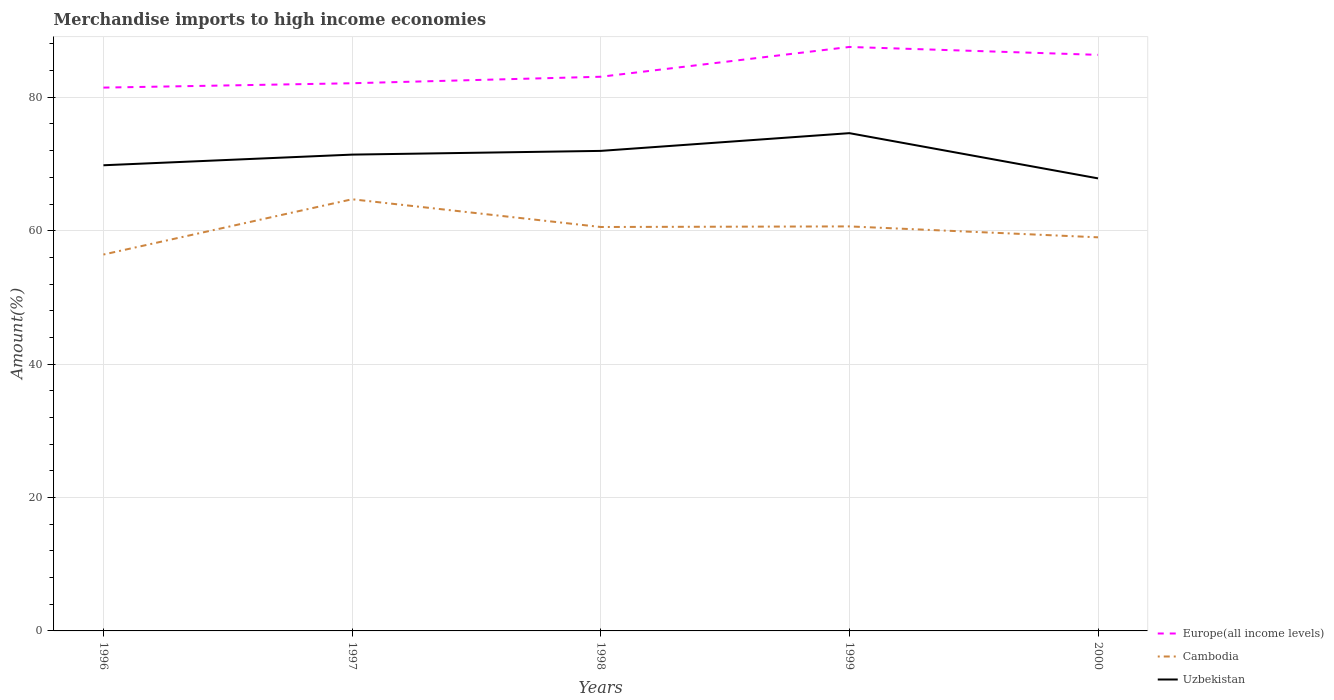Is the number of lines equal to the number of legend labels?
Make the answer very short. Yes. Across all years, what is the maximum percentage of amount earned from merchandise imports in Europe(all income levels)?
Give a very brief answer. 81.45. What is the total percentage of amount earned from merchandise imports in Cambodia in the graph?
Make the answer very short. 1.64. What is the difference between the highest and the second highest percentage of amount earned from merchandise imports in Uzbekistan?
Your answer should be very brief. 6.78. Is the percentage of amount earned from merchandise imports in Uzbekistan strictly greater than the percentage of amount earned from merchandise imports in Cambodia over the years?
Offer a terse response. No. How many years are there in the graph?
Ensure brevity in your answer.  5. Are the values on the major ticks of Y-axis written in scientific E-notation?
Provide a short and direct response. No. How many legend labels are there?
Offer a terse response. 3. How are the legend labels stacked?
Give a very brief answer. Vertical. What is the title of the graph?
Provide a short and direct response. Merchandise imports to high income economies. Does "South Africa" appear as one of the legend labels in the graph?
Make the answer very short. No. What is the label or title of the X-axis?
Your answer should be very brief. Years. What is the label or title of the Y-axis?
Your answer should be compact. Amount(%). What is the Amount(%) in Europe(all income levels) in 1996?
Your answer should be compact. 81.45. What is the Amount(%) of Cambodia in 1996?
Provide a succinct answer. 56.43. What is the Amount(%) of Uzbekistan in 1996?
Make the answer very short. 69.81. What is the Amount(%) of Europe(all income levels) in 1997?
Make the answer very short. 82.1. What is the Amount(%) of Cambodia in 1997?
Ensure brevity in your answer.  64.71. What is the Amount(%) in Uzbekistan in 1997?
Your response must be concise. 71.41. What is the Amount(%) of Europe(all income levels) in 1998?
Your answer should be compact. 83.08. What is the Amount(%) of Cambodia in 1998?
Provide a short and direct response. 60.55. What is the Amount(%) of Uzbekistan in 1998?
Ensure brevity in your answer.  71.96. What is the Amount(%) of Europe(all income levels) in 1999?
Ensure brevity in your answer.  87.55. What is the Amount(%) in Cambodia in 1999?
Your response must be concise. 60.64. What is the Amount(%) of Uzbekistan in 1999?
Give a very brief answer. 74.62. What is the Amount(%) in Europe(all income levels) in 2000?
Make the answer very short. 86.36. What is the Amount(%) in Cambodia in 2000?
Your response must be concise. 59.01. What is the Amount(%) of Uzbekistan in 2000?
Your response must be concise. 67.84. Across all years, what is the maximum Amount(%) in Europe(all income levels)?
Your response must be concise. 87.55. Across all years, what is the maximum Amount(%) of Cambodia?
Offer a terse response. 64.71. Across all years, what is the maximum Amount(%) of Uzbekistan?
Keep it short and to the point. 74.62. Across all years, what is the minimum Amount(%) of Europe(all income levels)?
Make the answer very short. 81.45. Across all years, what is the minimum Amount(%) in Cambodia?
Provide a succinct answer. 56.43. Across all years, what is the minimum Amount(%) of Uzbekistan?
Offer a terse response. 67.84. What is the total Amount(%) in Europe(all income levels) in the graph?
Your answer should be compact. 420.54. What is the total Amount(%) in Cambodia in the graph?
Provide a short and direct response. 301.34. What is the total Amount(%) in Uzbekistan in the graph?
Keep it short and to the point. 355.65. What is the difference between the Amount(%) in Europe(all income levels) in 1996 and that in 1997?
Your answer should be compact. -0.65. What is the difference between the Amount(%) in Cambodia in 1996 and that in 1997?
Ensure brevity in your answer.  -8.29. What is the difference between the Amount(%) of Uzbekistan in 1996 and that in 1997?
Provide a short and direct response. -1.6. What is the difference between the Amount(%) of Europe(all income levels) in 1996 and that in 1998?
Provide a short and direct response. -1.63. What is the difference between the Amount(%) of Cambodia in 1996 and that in 1998?
Provide a succinct answer. -4.13. What is the difference between the Amount(%) in Uzbekistan in 1996 and that in 1998?
Provide a short and direct response. -2.15. What is the difference between the Amount(%) of Europe(all income levels) in 1996 and that in 1999?
Give a very brief answer. -6.09. What is the difference between the Amount(%) of Cambodia in 1996 and that in 1999?
Provide a succinct answer. -4.22. What is the difference between the Amount(%) in Uzbekistan in 1996 and that in 1999?
Provide a succinct answer. -4.81. What is the difference between the Amount(%) of Europe(all income levels) in 1996 and that in 2000?
Provide a short and direct response. -4.91. What is the difference between the Amount(%) in Cambodia in 1996 and that in 2000?
Ensure brevity in your answer.  -2.58. What is the difference between the Amount(%) of Uzbekistan in 1996 and that in 2000?
Offer a terse response. 1.97. What is the difference between the Amount(%) in Europe(all income levels) in 1997 and that in 1998?
Provide a succinct answer. -0.97. What is the difference between the Amount(%) of Cambodia in 1997 and that in 1998?
Keep it short and to the point. 4.16. What is the difference between the Amount(%) in Uzbekistan in 1997 and that in 1998?
Your response must be concise. -0.56. What is the difference between the Amount(%) of Europe(all income levels) in 1997 and that in 1999?
Your answer should be very brief. -5.44. What is the difference between the Amount(%) of Cambodia in 1997 and that in 1999?
Your answer should be very brief. 4.07. What is the difference between the Amount(%) of Uzbekistan in 1997 and that in 1999?
Offer a very short reply. -3.22. What is the difference between the Amount(%) in Europe(all income levels) in 1997 and that in 2000?
Provide a short and direct response. -4.26. What is the difference between the Amount(%) of Cambodia in 1997 and that in 2000?
Keep it short and to the point. 5.7. What is the difference between the Amount(%) in Uzbekistan in 1997 and that in 2000?
Provide a short and direct response. 3.56. What is the difference between the Amount(%) of Europe(all income levels) in 1998 and that in 1999?
Offer a very short reply. -4.47. What is the difference between the Amount(%) of Cambodia in 1998 and that in 1999?
Your answer should be compact. -0.09. What is the difference between the Amount(%) in Uzbekistan in 1998 and that in 1999?
Your answer should be compact. -2.66. What is the difference between the Amount(%) in Europe(all income levels) in 1998 and that in 2000?
Provide a short and direct response. -3.28. What is the difference between the Amount(%) in Cambodia in 1998 and that in 2000?
Your answer should be very brief. 1.55. What is the difference between the Amount(%) of Uzbekistan in 1998 and that in 2000?
Your answer should be compact. 4.12. What is the difference between the Amount(%) in Europe(all income levels) in 1999 and that in 2000?
Offer a very short reply. 1.18. What is the difference between the Amount(%) in Cambodia in 1999 and that in 2000?
Provide a short and direct response. 1.64. What is the difference between the Amount(%) of Uzbekistan in 1999 and that in 2000?
Provide a succinct answer. 6.78. What is the difference between the Amount(%) in Europe(all income levels) in 1996 and the Amount(%) in Cambodia in 1997?
Give a very brief answer. 16.74. What is the difference between the Amount(%) in Europe(all income levels) in 1996 and the Amount(%) in Uzbekistan in 1997?
Give a very brief answer. 10.04. What is the difference between the Amount(%) of Cambodia in 1996 and the Amount(%) of Uzbekistan in 1997?
Provide a short and direct response. -14.98. What is the difference between the Amount(%) in Europe(all income levels) in 1996 and the Amount(%) in Cambodia in 1998?
Keep it short and to the point. 20.9. What is the difference between the Amount(%) of Europe(all income levels) in 1996 and the Amount(%) of Uzbekistan in 1998?
Offer a very short reply. 9.49. What is the difference between the Amount(%) of Cambodia in 1996 and the Amount(%) of Uzbekistan in 1998?
Ensure brevity in your answer.  -15.54. What is the difference between the Amount(%) in Europe(all income levels) in 1996 and the Amount(%) in Cambodia in 1999?
Keep it short and to the point. 20.81. What is the difference between the Amount(%) of Europe(all income levels) in 1996 and the Amount(%) of Uzbekistan in 1999?
Ensure brevity in your answer.  6.83. What is the difference between the Amount(%) of Cambodia in 1996 and the Amount(%) of Uzbekistan in 1999?
Keep it short and to the point. -18.2. What is the difference between the Amount(%) in Europe(all income levels) in 1996 and the Amount(%) in Cambodia in 2000?
Offer a very short reply. 22.44. What is the difference between the Amount(%) of Europe(all income levels) in 1996 and the Amount(%) of Uzbekistan in 2000?
Provide a succinct answer. 13.61. What is the difference between the Amount(%) of Cambodia in 1996 and the Amount(%) of Uzbekistan in 2000?
Ensure brevity in your answer.  -11.42. What is the difference between the Amount(%) in Europe(all income levels) in 1997 and the Amount(%) in Cambodia in 1998?
Your answer should be very brief. 21.55. What is the difference between the Amount(%) in Europe(all income levels) in 1997 and the Amount(%) in Uzbekistan in 1998?
Offer a terse response. 10.14. What is the difference between the Amount(%) of Cambodia in 1997 and the Amount(%) of Uzbekistan in 1998?
Provide a succinct answer. -7.25. What is the difference between the Amount(%) of Europe(all income levels) in 1997 and the Amount(%) of Cambodia in 1999?
Provide a succinct answer. 21.46. What is the difference between the Amount(%) in Europe(all income levels) in 1997 and the Amount(%) in Uzbekistan in 1999?
Make the answer very short. 7.48. What is the difference between the Amount(%) of Cambodia in 1997 and the Amount(%) of Uzbekistan in 1999?
Offer a terse response. -9.91. What is the difference between the Amount(%) of Europe(all income levels) in 1997 and the Amount(%) of Cambodia in 2000?
Your answer should be compact. 23.1. What is the difference between the Amount(%) of Europe(all income levels) in 1997 and the Amount(%) of Uzbekistan in 2000?
Your answer should be compact. 14.26. What is the difference between the Amount(%) of Cambodia in 1997 and the Amount(%) of Uzbekistan in 2000?
Your answer should be compact. -3.13. What is the difference between the Amount(%) of Europe(all income levels) in 1998 and the Amount(%) of Cambodia in 1999?
Offer a terse response. 22.44. What is the difference between the Amount(%) of Europe(all income levels) in 1998 and the Amount(%) of Uzbekistan in 1999?
Provide a succinct answer. 8.46. What is the difference between the Amount(%) in Cambodia in 1998 and the Amount(%) in Uzbekistan in 1999?
Make the answer very short. -14.07. What is the difference between the Amount(%) in Europe(all income levels) in 1998 and the Amount(%) in Cambodia in 2000?
Your response must be concise. 24.07. What is the difference between the Amount(%) in Europe(all income levels) in 1998 and the Amount(%) in Uzbekistan in 2000?
Offer a very short reply. 15.23. What is the difference between the Amount(%) in Cambodia in 1998 and the Amount(%) in Uzbekistan in 2000?
Your answer should be compact. -7.29. What is the difference between the Amount(%) of Europe(all income levels) in 1999 and the Amount(%) of Cambodia in 2000?
Give a very brief answer. 28.54. What is the difference between the Amount(%) in Europe(all income levels) in 1999 and the Amount(%) in Uzbekistan in 2000?
Offer a very short reply. 19.7. What is the difference between the Amount(%) of Cambodia in 1999 and the Amount(%) of Uzbekistan in 2000?
Offer a terse response. -7.2. What is the average Amount(%) of Europe(all income levels) per year?
Offer a very short reply. 84.11. What is the average Amount(%) in Cambodia per year?
Provide a succinct answer. 60.27. What is the average Amount(%) of Uzbekistan per year?
Your answer should be compact. 71.13. In the year 1996, what is the difference between the Amount(%) of Europe(all income levels) and Amount(%) of Cambodia?
Provide a short and direct response. 25.03. In the year 1996, what is the difference between the Amount(%) in Europe(all income levels) and Amount(%) in Uzbekistan?
Offer a terse response. 11.64. In the year 1996, what is the difference between the Amount(%) in Cambodia and Amount(%) in Uzbekistan?
Offer a terse response. -13.38. In the year 1997, what is the difference between the Amount(%) of Europe(all income levels) and Amount(%) of Cambodia?
Provide a succinct answer. 17.39. In the year 1997, what is the difference between the Amount(%) of Europe(all income levels) and Amount(%) of Uzbekistan?
Provide a short and direct response. 10.7. In the year 1997, what is the difference between the Amount(%) of Cambodia and Amount(%) of Uzbekistan?
Make the answer very short. -6.69. In the year 1998, what is the difference between the Amount(%) of Europe(all income levels) and Amount(%) of Cambodia?
Keep it short and to the point. 22.52. In the year 1998, what is the difference between the Amount(%) in Europe(all income levels) and Amount(%) in Uzbekistan?
Your answer should be compact. 11.11. In the year 1998, what is the difference between the Amount(%) of Cambodia and Amount(%) of Uzbekistan?
Offer a very short reply. -11.41. In the year 1999, what is the difference between the Amount(%) of Europe(all income levels) and Amount(%) of Cambodia?
Your response must be concise. 26.9. In the year 1999, what is the difference between the Amount(%) of Europe(all income levels) and Amount(%) of Uzbekistan?
Your response must be concise. 12.92. In the year 1999, what is the difference between the Amount(%) of Cambodia and Amount(%) of Uzbekistan?
Your response must be concise. -13.98. In the year 2000, what is the difference between the Amount(%) of Europe(all income levels) and Amount(%) of Cambodia?
Offer a terse response. 27.35. In the year 2000, what is the difference between the Amount(%) in Europe(all income levels) and Amount(%) in Uzbekistan?
Your answer should be compact. 18.52. In the year 2000, what is the difference between the Amount(%) in Cambodia and Amount(%) in Uzbekistan?
Provide a succinct answer. -8.84. What is the ratio of the Amount(%) of Europe(all income levels) in 1996 to that in 1997?
Give a very brief answer. 0.99. What is the ratio of the Amount(%) in Cambodia in 1996 to that in 1997?
Your answer should be very brief. 0.87. What is the ratio of the Amount(%) in Uzbekistan in 1996 to that in 1997?
Ensure brevity in your answer.  0.98. What is the ratio of the Amount(%) in Europe(all income levels) in 1996 to that in 1998?
Your answer should be compact. 0.98. What is the ratio of the Amount(%) in Cambodia in 1996 to that in 1998?
Keep it short and to the point. 0.93. What is the ratio of the Amount(%) of Uzbekistan in 1996 to that in 1998?
Your response must be concise. 0.97. What is the ratio of the Amount(%) in Europe(all income levels) in 1996 to that in 1999?
Offer a very short reply. 0.93. What is the ratio of the Amount(%) in Cambodia in 1996 to that in 1999?
Offer a very short reply. 0.93. What is the ratio of the Amount(%) of Uzbekistan in 1996 to that in 1999?
Make the answer very short. 0.94. What is the ratio of the Amount(%) of Europe(all income levels) in 1996 to that in 2000?
Your response must be concise. 0.94. What is the ratio of the Amount(%) in Cambodia in 1996 to that in 2000?
Keep it short and to the point. 0.96. What is the ratio of the Amount(%) in Uzbekistan in 1996 to that in 2000?
Your response must be concise. 1.03. What is the ratio of the Amount(%) in Europe(all income levels) in 1997 to that in 1998?
Offer a terse response. 0.99. What is the ratio of the Amount(%) in Cambodia in 1997 to that in 1998?
Offer a very short reply. 1.07. What is the ratio of the Amount(%) in Europe(all income levels) in 1997 to that in 1999?
Provide a short and direct response. 0.94. What is the ratio of the Amount(%) in Cambodia in 1997 to that in 1999?
Your answer should be compact. 1.07. What is the ratio of the Amount(%) in Uzbekistan in 1997 to that in 1999?
Your answer should be compact. 0.96. What is the ratio of the Amount(%) of Europe(all income levels) in 1997 to that in 2000?
Provide a succinct answer. 0.95. What is the ratio of the Amount(%) of Cambodia in 1997 to that in 2000?
Keep it short and to the point. 1.1. What is the ratio of the Amount(%) of Uzbekistan in 1997 to that in 2000?
Give a very brief answer. 1.05. What is the ratio of the Amount(%) in Europe(all income levels) in 1998 to that in 1999?
Provide a succinct answer. 0.95. What is the ratio of the Amount(%) in Uzbekistan in 1998 to that in 1999?
Ensure brevity in your answer.  0.96. What is the ratio of the Amount(%) of Europe(all income levels) in 1998 to that in 2000?
Give a very brief answer. 0.96. What is the ratio of the Amount(%) in Cambodia in 1998 to that in 2000?
Ensure brevity in your answer.  1.03. What is the ratio of the Amount(%) of Uzbekistan in 1998 to that in 2000?
Your answer should be very brief. 1.06. What is the ratio of the Amount(%) in Europe(all income levels) in 1999 to that in 2000?
Offer a very short reply. 1.01. What is the ratio of the Amount(%) of Cambodia in 1999 to that in 2000?
Offer a very short reply. 1.03. What is the ratio of the Amount(%) of Uzbekistan in 1999 to that in 2000?
Provide a short and direct response. 1.1. What is the difference between the highest and the second highest Amount(%) in Europe(all income levels)?
Provide a short and direct response. 1.18. What is the difference between the highest and the second highest Amount(%) in Cambodia?
Keep it short and to the point. 4.07. What is the difference between the highest and the second highest Amount(%) in Uzbekistan?
Give a very brief answer. 2.66. What is the difference between the highest and the lowest Amount(%) in Europe(all income levels)?
Your response must be concise. 6.09. What is the difference between the highest and the lowest Amount(%) in Cambodia?
Your answer should be very brief. 8.29. What is the difference between the highest and the lowest Amount(%) of Uzbekistan?
Make the answer very short. 6.78. 